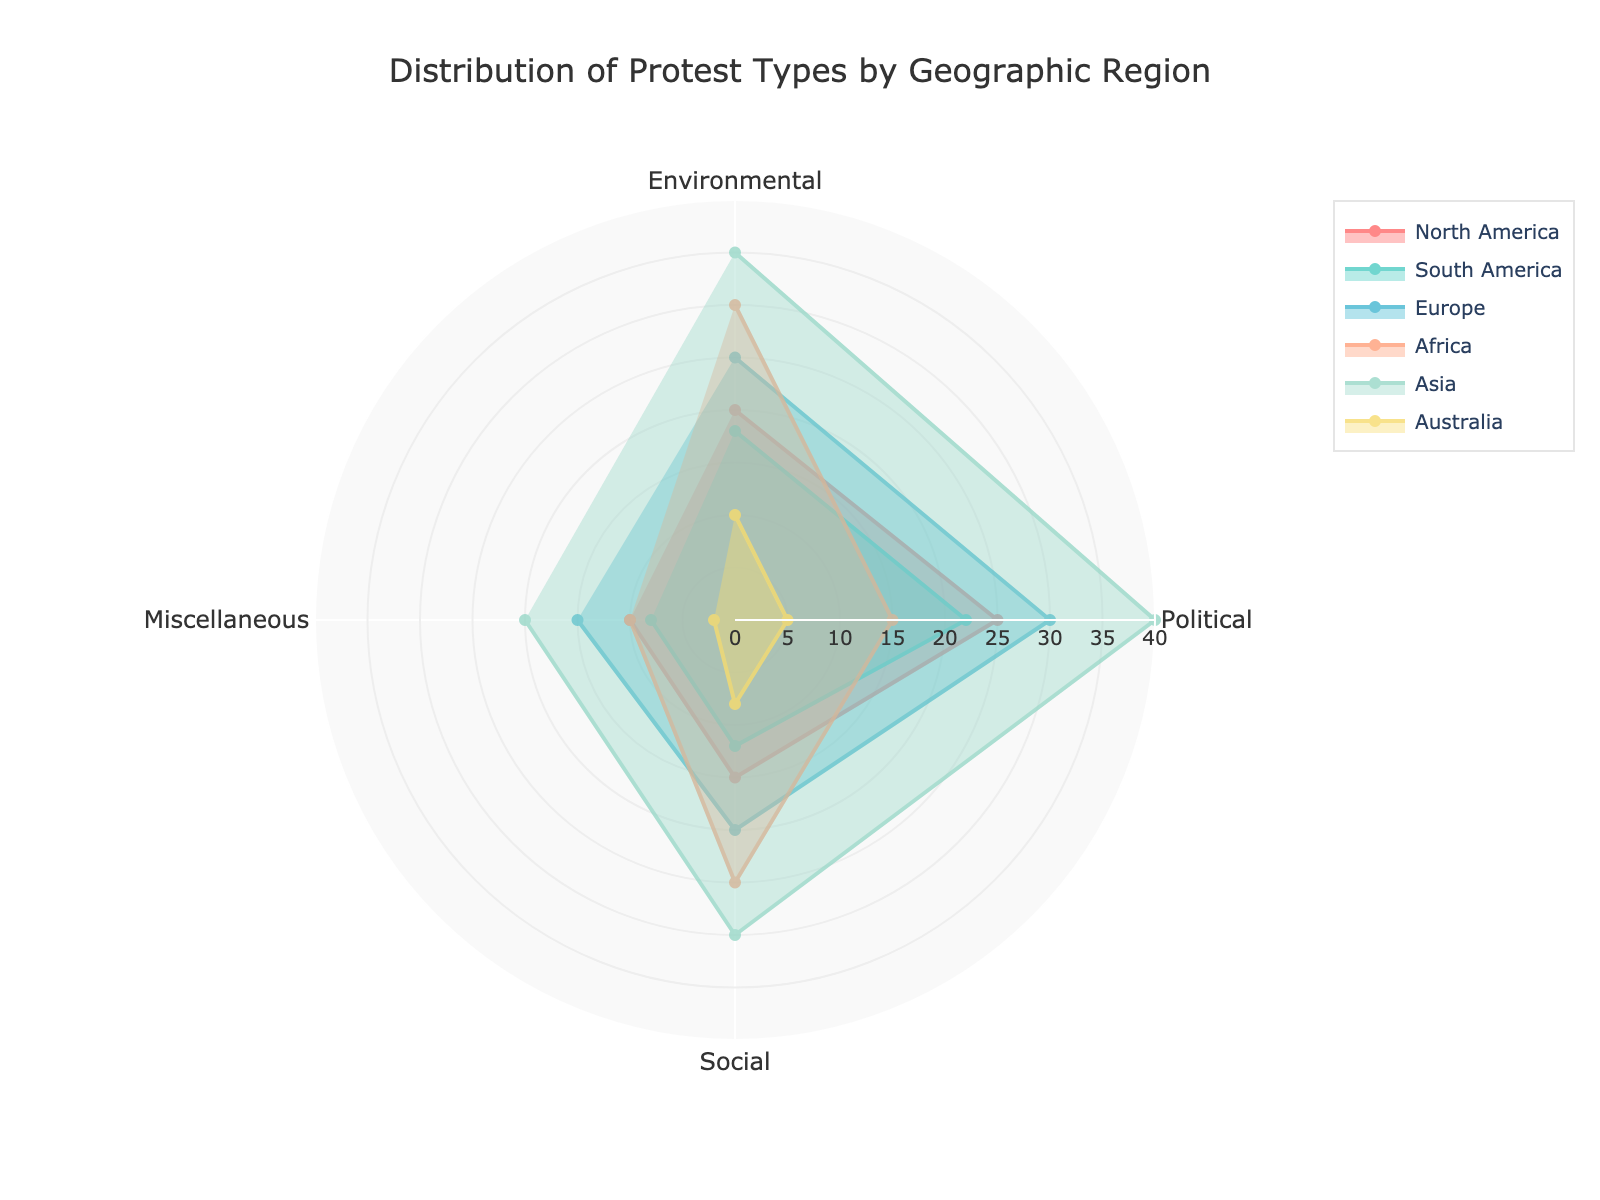what's the title of the figure? The title is usually located at the top of the figure and provides an overview of what the figure is about. In this case, it is "Distribution of Protest Types by Geographic Region."
Answer: Distribution of Protest Types by Geographic Region how many categories of protest types are shown on the chart? The categories of protest types are clearly labeled around the polar chart. Counting them gives us the number of different types. These are "Environmental," "Political," "Social," and "Miscellaneous," which totals 4.
Answer: 4 which region shows the highest number of environmental protests? To answer this, we need to look at the "Environmental" value for each region on the polar chart. The region with the highest value in this category is Asia.
Answer: Asia what is the difference in the number of political protests between Europe and Australia? We need to find the "Political" value for both Europe and Australia and then subtract the smaller from the larger. Europe has 30 political protests and Australia has 5, so the difference is 30 - 5 = 25.
Answer: 25 which regions have a higher number of social protests than Africa? According to the chart, Africa has 25 social protests. We need to compare this with the values for each region. North America, South America, Europe, and Asia all have more social protests than Africa.
Answer: North America, South America, Europe, Asia what is the sum of miscellaneous protests for South America and Africa? We need to look at the "Miscellaneous" values for South America and Africa. South America has 8 and Africa has 10. Adding them together gives us 8 + 10 = 18.
Answer: 18 which region has the most balanced distribution of protest types? A balanced distribution means that the values for environmental, political, social, and miscellaneous protests are relatively similar. Looking at the polar chart, Europe seems to have the most balanced distribution with fairly even values.
Answer: Europe how does the distribution of protest types in Australia compare to that in North America? Comparing the sections of the polar chart for Australia and North America, North America has consistently higher values across all protest types (Environmental, Political, Social, Miscellaneous) compared to Australia.
Answer: North America's values are higher across all categories what regions have their highest value in the Political protest category? To find this, we need to look at each region's values and see where Political is the highest compared to the other protest types. For both Europe (30) and Asia (40), Political is the highest category.
Answer: Europe, Asia 